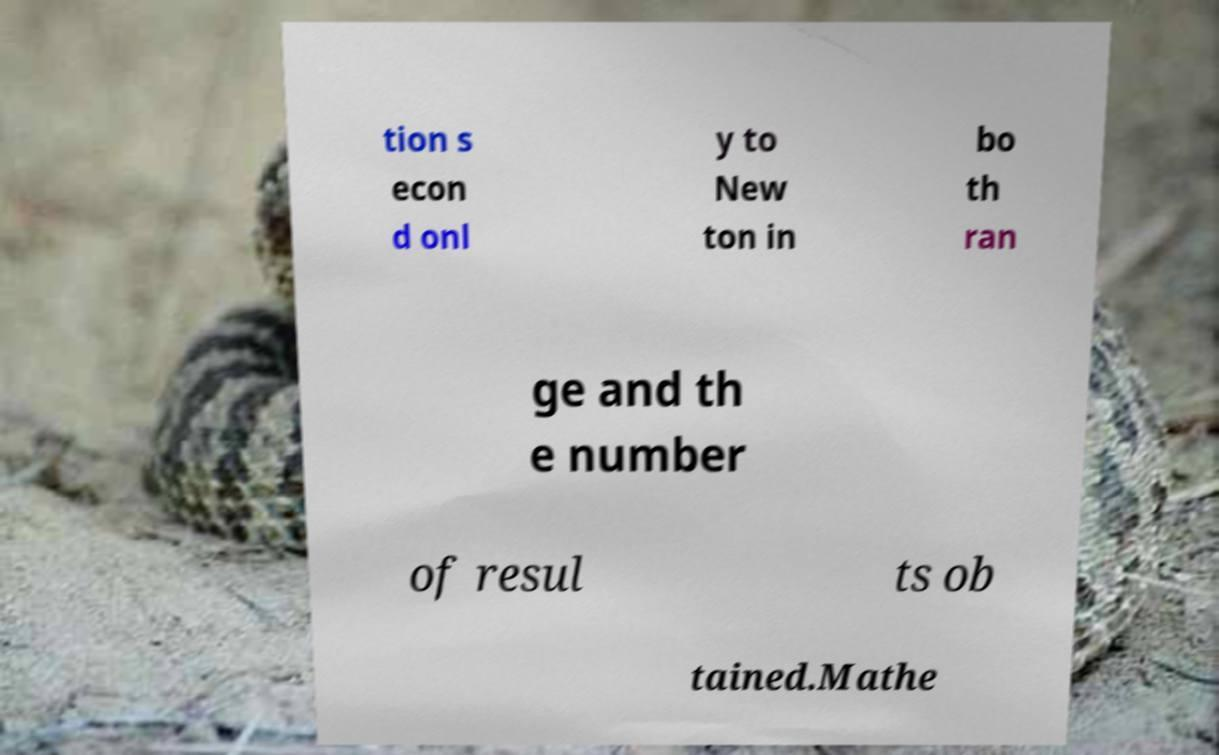What messages or text are displayed in this image? I need them in a readable, typed format. tion s econ d onl y to New ton in bo th ran ge and th e number of resul ts ob tained.Mathe 